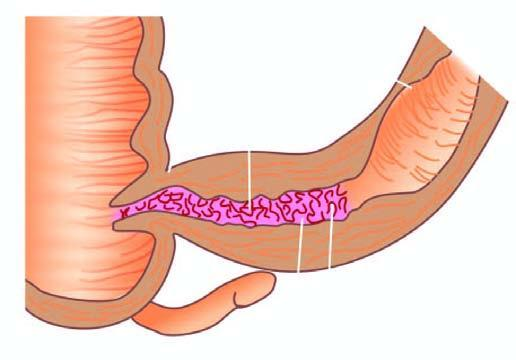how does luminal surface of longitudinal cut section show segment of thickened wall?
Answer the question using a single word or phrase. With narrow lumen 